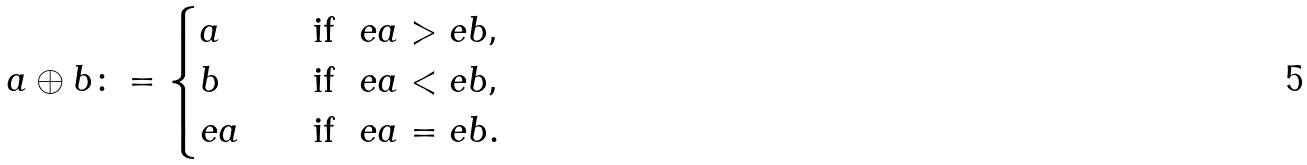<formula> <loc_0><loc_0><loc_500><loc_500>a \oplus b \colon = \begin{cases} a & \quad \text {if \ $ea>eb$,} \\ b & \quad \text {if \ $ea<eb$,} \\ e a & \quad \text {if } \ e a = e b . \end{cases}</formula> 